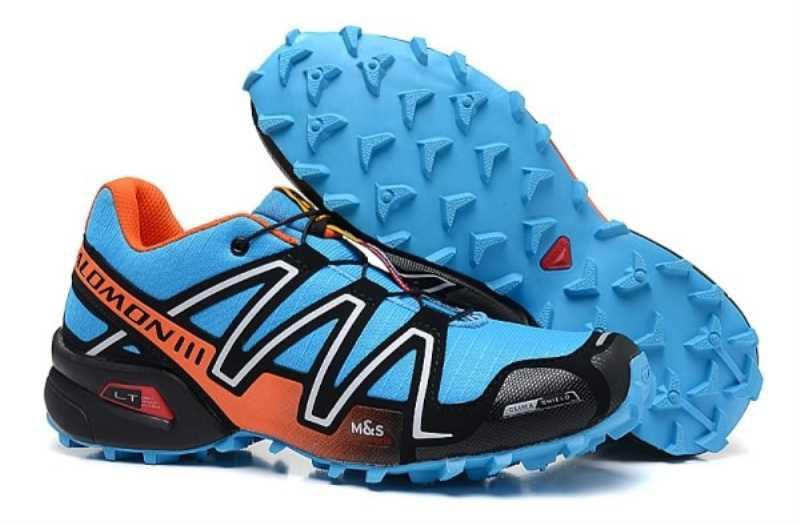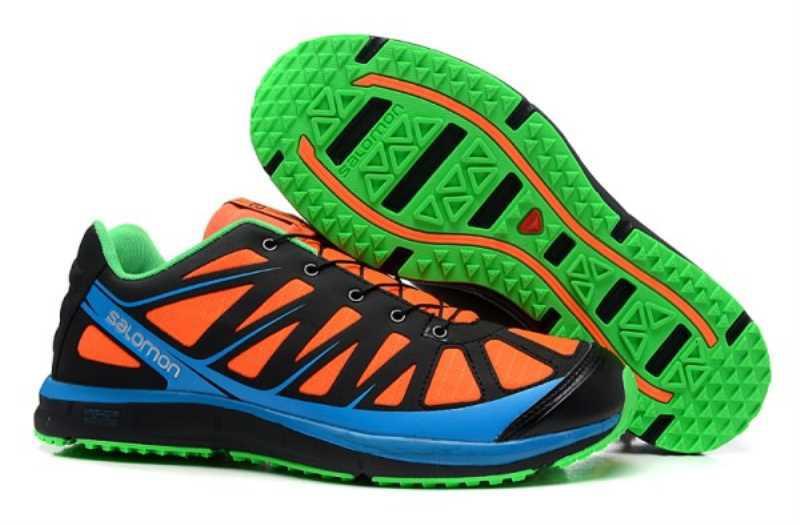The first image is the image on the left, the second image is the image on the right. Considering the images on both sides, is "One image contains at least 6 pairs of shoes." valid? Answer yes or no. No. The first image is the image on the left, the second image is the image on the right. For the images displayed, is the sentence "Each image includes exactly one pair of sneakers." factually correct? Answer yes or no. Yes. 